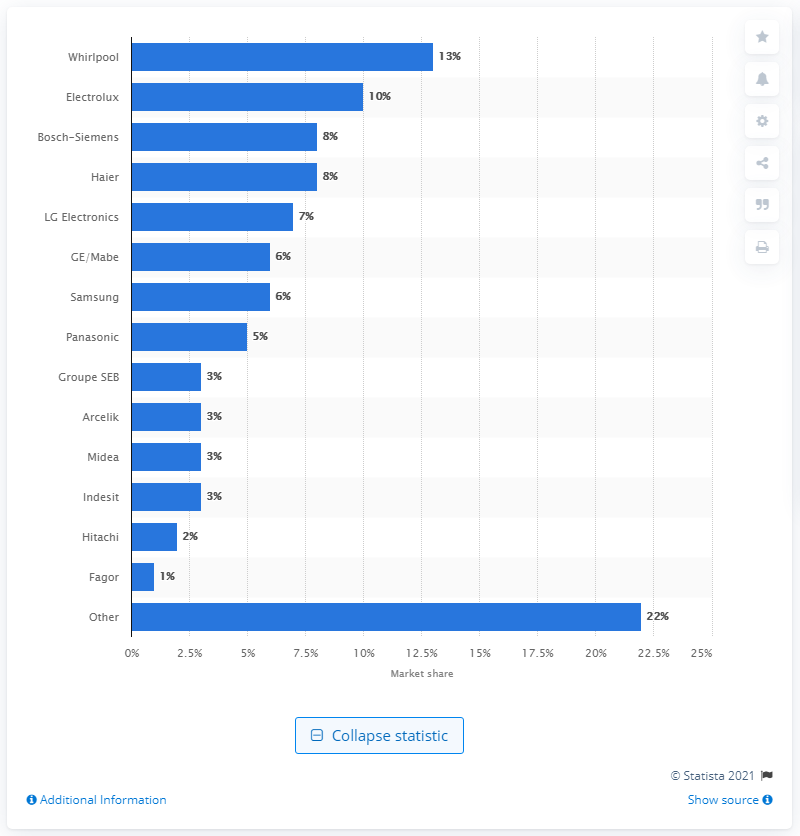List a handful of essential elements in this visual. According to data from 2012, LG Electronics held a market share of 7 percent in the global domestic appliances market. 